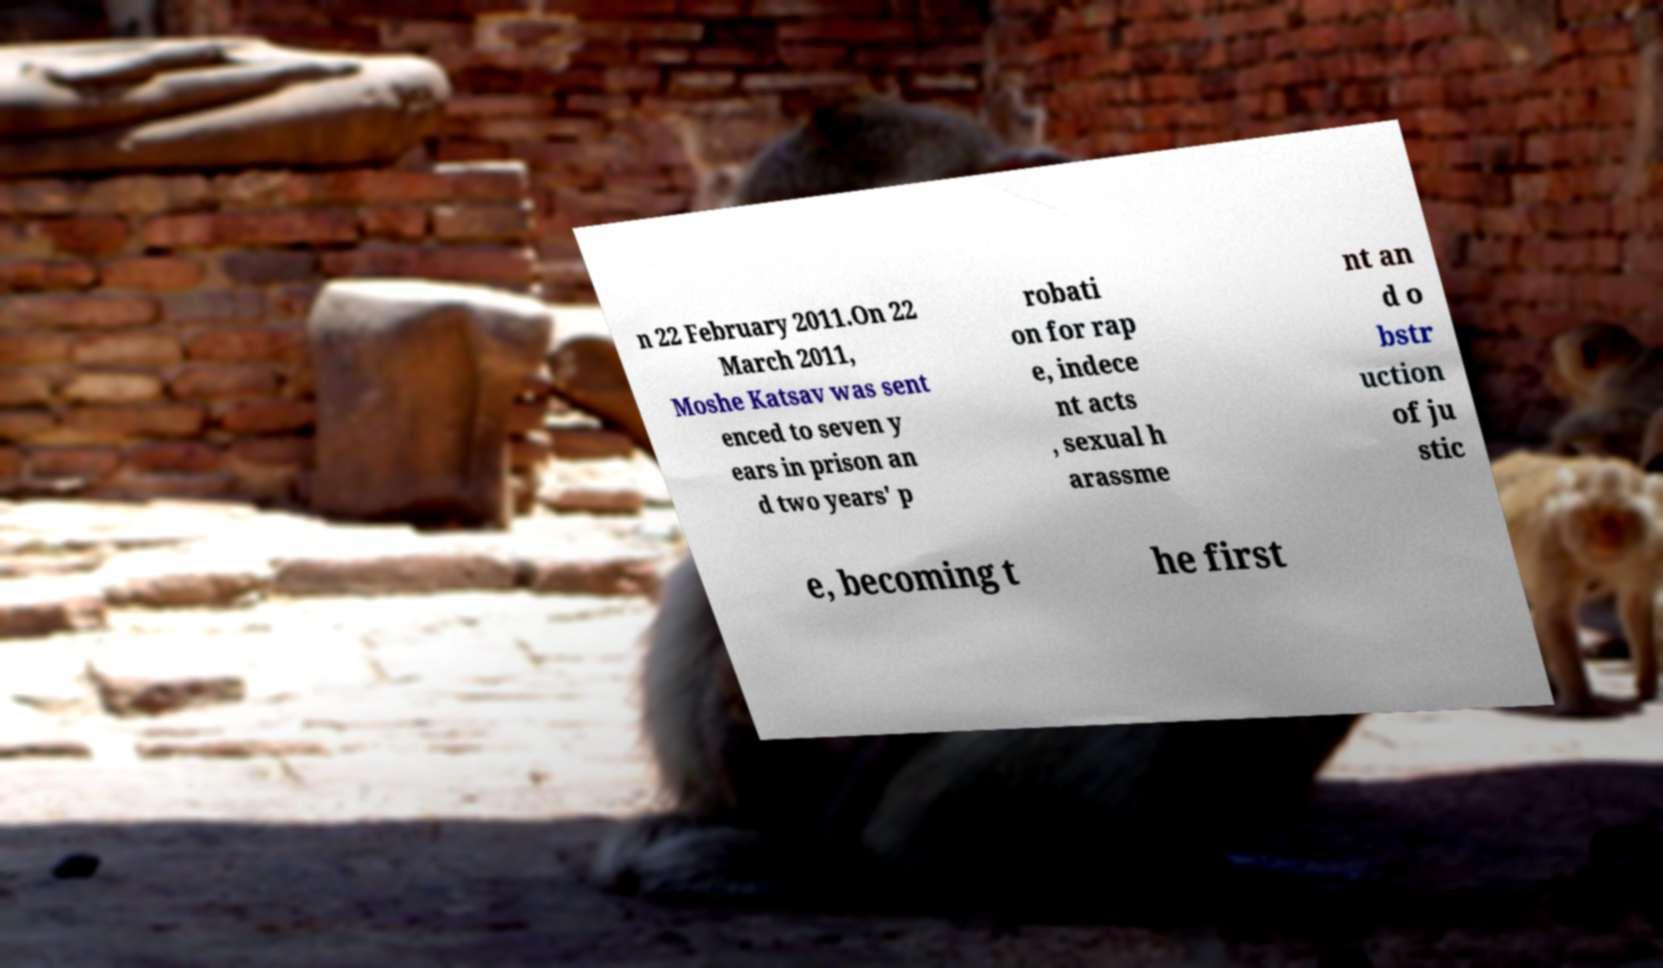Please read and relay the text visible in this image. What does it say? n 22 February 2011.On 22 March 2011, Moshe Katsav was sent enced to seven y ears in prison an d two years' p robati on for rap e, indece nt acts , sexual h arassme nt an d o bstr uction of ju stic e, becoming t he first 